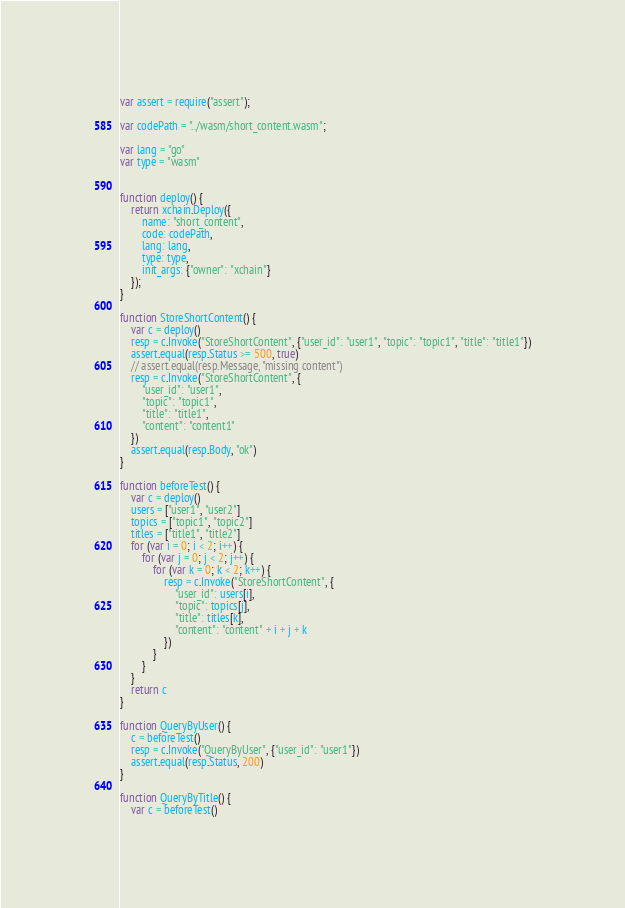Convert code to text. <code><loc_0><loc_0><loc_500><loc_500><_JavaScript_>var assert = require("assert");

var codePath = "../wasm/short_content.wasm";

var lang = "go"
var type = "wasm"


function deploy() {
    return xchain.Deploy({
        name: "short_content",
        code: codePath,
        lang: lang,
        type: type,
        init_args: {"owner": "xchain"}
    });
}

function StoreShortContent() {
    var c = deploy()
    resp = c.Invoke("StoreShortContent", {"user_id": "user1", "topic": "topic1", "title": "title1"})
    assert.equal(resp.Status >= 500, true)
    // assert.equal(resp.Message, "missing content")
    resp = c.Invoke("StoreShortContent", {
        "user_id": "user1",
        "topic": "topic1",
        "title": "title1",
        "content": "content1"
    })
    assert.equal(resp.Body, "ok")
}

function beforeTest() {
    var c = deploy()
    users = ["user1", "user2"]
    topics = ["topic1", "topic2"]
    titles = ["title1", "title2"]
    for (var i = 0; i < 2; i++) {
        for (var j = 0; j < 2; j++) {
            for (var k = 0; k < 2; k++) {
                resp = c.Invoke("StoreShortContent", {
                    "user_id": users[i],
                    "topic": topics[j],
                    "title": titles[k],
                    "content": "content" + i + j + k
                })
            }
        }
    }
    return c
}

function QueryByUser() {
    c = beforeTest()
    resp = c.Invoke("QueryByUser", {"user_id": "user1"})
    assert.equal(resp.Status, 200)
}

function QueryByTitle() {
    var c = beforeTest()</code> 